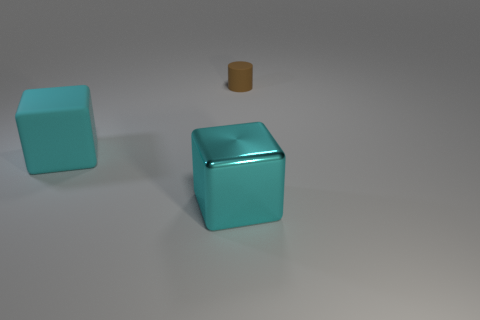Add 3 large cyan rubber things. How many objects exist? 6 Subtract all cubes. How many objects are left? 1 Subtract 1 blocks. How many blocks are left? 1 Subtract all blue blocks. Subtract all brown balls. How many blocks are left? 2 Subtract all green cubes. How many green cylinders are left? 0 Subtract all big gray cylinders. Subtract all tiny brown rubber objects. How many objects are left? 2 Add 3 large cyan things. How many large cyan things are left? 5 Add 1 blue blocks. How many blue blocks exist? 1 Subtract 0 red cubes. How many objects are left? 3 